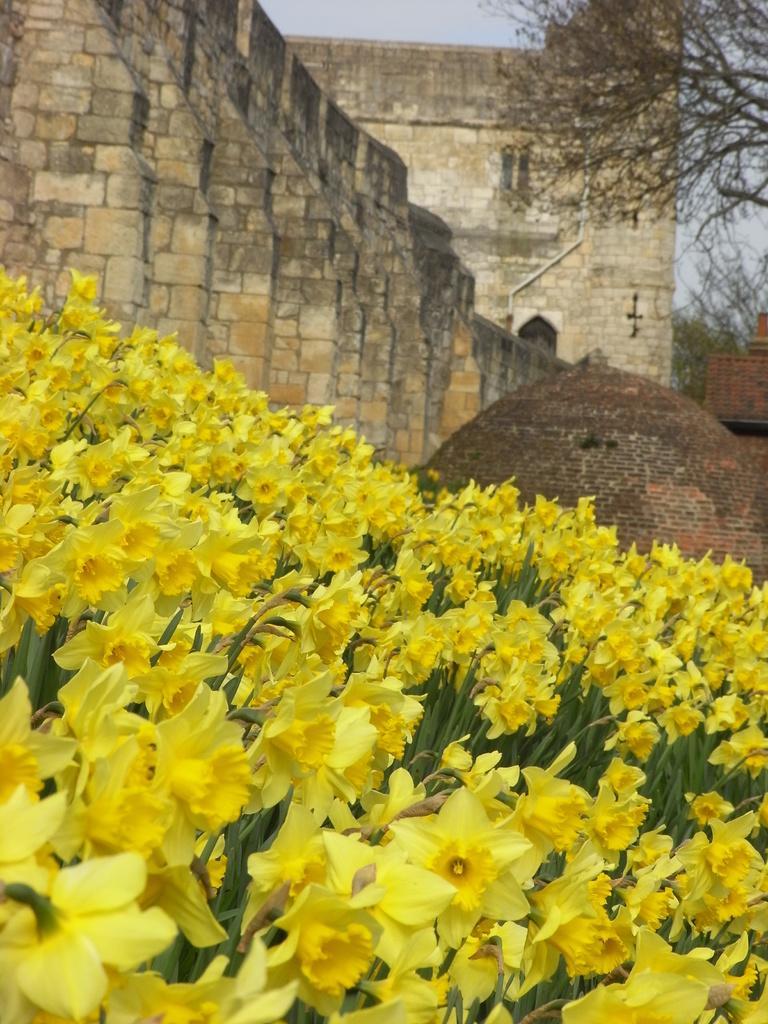Describe this image in one or two sentences. In this picture we can see a few yellow flowers at the bottom of the picture. We can see a dome shape object and an object on the right side. There is a wall, a building and a few trees in the background. 